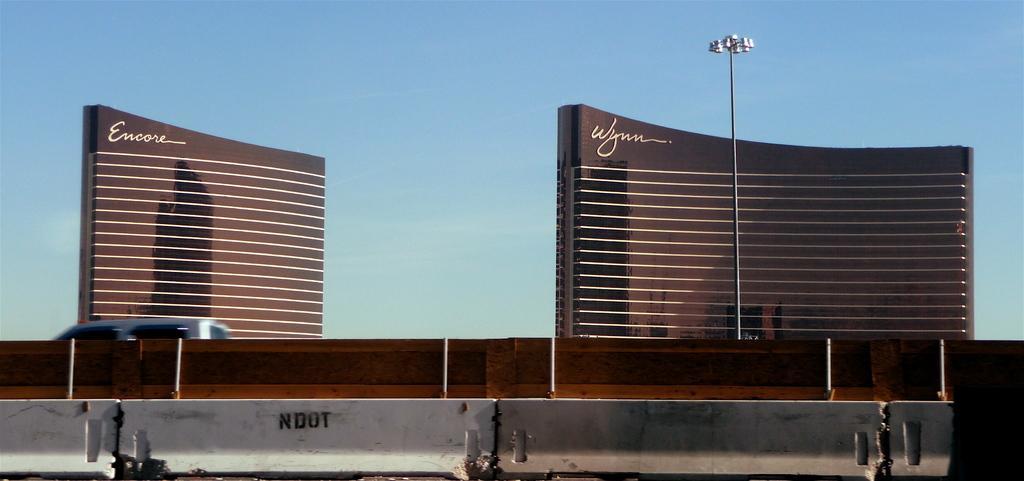Please provide a concise description of this image. In this image, there are buildings, a vehicle, wall and lights to a pole. At the bottom of the image, I can see jersey barriers. In the background there is the sky. 